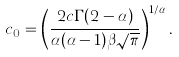<formula> <loc_0><loc_0><loc_500><loc_500>c _ { 0 } = \left ( \frac { 2 c \Gamma ( 2 - \alpha ) } { \alpha ( \alpha - 1 ) \beta \sqrt { \pi } } \right ) ^ { 1 / \alpha } .</formula> 